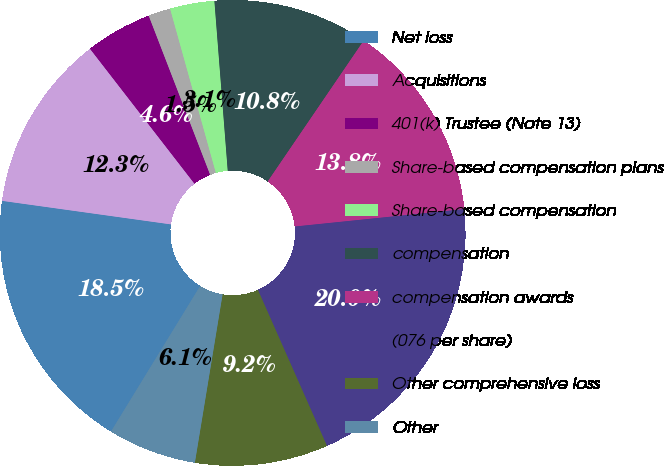<chart> <loc_0><loc_0><loc_500><loc_500><pie_chart><fcel>Net loss<fcel>Acquisitions<fcel>401(k) Trustee (Note 13)<fcel>Share-based compensation plans<fcel>Share-based compensation<fcel>compensation<fcel>compensation awards<fcel>(076 per share)<fcel>Other comprehensive loss<fcel>Other<nl><fcel>18.46%<fcel>12.31%<fcel>4.62%<fcel>1.54%<fcel>3.08%<fcel>10.77%<fcel>13.85%<fcel>20.0%<fcel>9.23%<fcel>6.15%<nl></chart> 